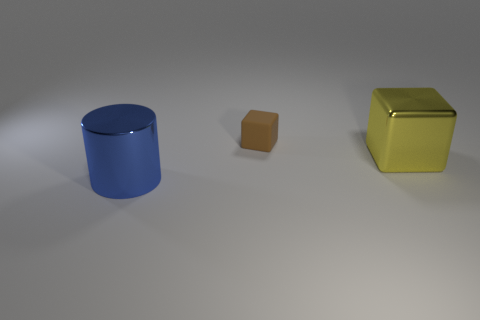Add 3 tiny green matte things. How many objects exist? 6 Subtract all brown cubes. How many cubes are left? 1 Subtract all cylinders. How many objects are left? 2 Add 3 yellow objects. How many yellow objects are left? 4 Add 2 blue shiny cylinders. How many blue shiny cylinders exist? 3 Subtract 0 red balls. How many objects are left? 3 Subtract 1 cylinders. How many cylinders are left? 0 Subtract all gray blocks. Subtract all red balls. How many blocks are left? 2 Subtract all tiny brown blocks. Subtract all large cylinders. How many objects are left? 1 